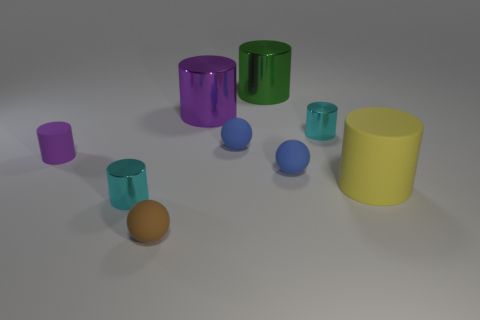Is the number of gray rubber cylinders greater than the number of blue spheres?
Offer a terse response. No. What material is the large purple object?
Give a very brief answer. Metal. There is a tiny ball that is in front of the big matte cylinder; how many small cyan cylinders are on the right side of it?
Give a very brief answer. 1. There is a small matte cylinder; does it have the same color as the ball that is right of the large green thing?
Your response must be concise. No. What is the color of the metallic object that is the same size as the purple shiny cylinder?
Give a very brief answer. Green. Is there a small gray metallic object of the same shape as the green thing?
Ensure brevity in your answer.  No. Is the number of green shiny cylinders less than the number of metal cylinders?
Ensure brevity in your answer.  Yes. There is a matte thing that is to the left of the tiny brown rubber sphere; what color is it?
Offer a very short reply. Purple. What is the shape of the metallic thing that is left of the ball that is in front of the large yellow matte thing?
Offer a terse response. Cylinder. Do the tiny brown sphere and the tiny cylinder that is in front of the purple rubber object have the same material?
Make the answer very short. No. 